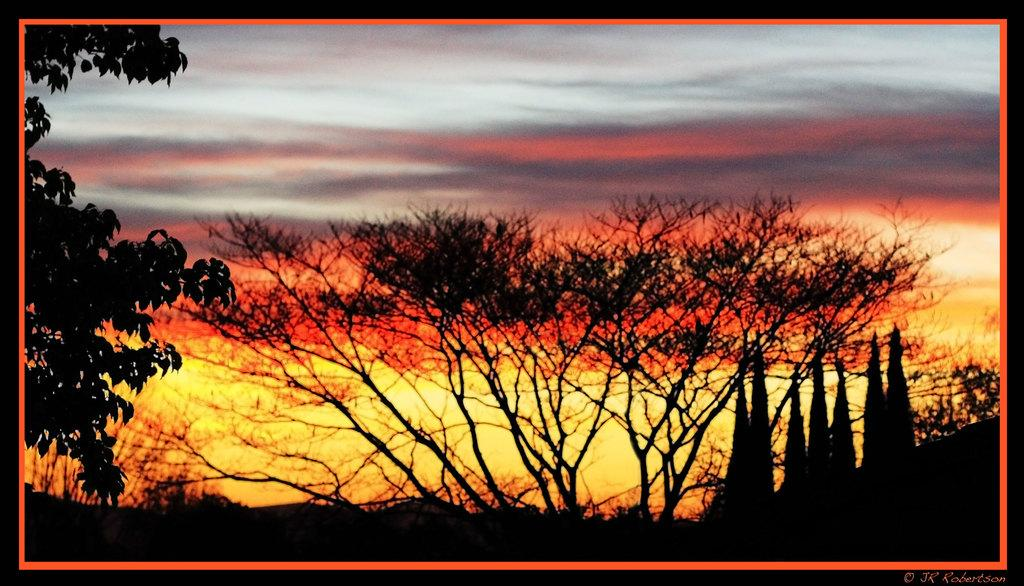What type of natural elements can be seen in the image? There are trees in the image. What time of day is suggested by the image? A sunset is visible in the background, suggesting that it is late afternoon or early evening. What is visible in the sky in the image? Clouds are present in the sky. What is written at the bottom of the image? There is text written at the bottom of the image. What type of table is visible in the image? There is no table present in the image; it primarily features natural elements and a sky with clouds. 